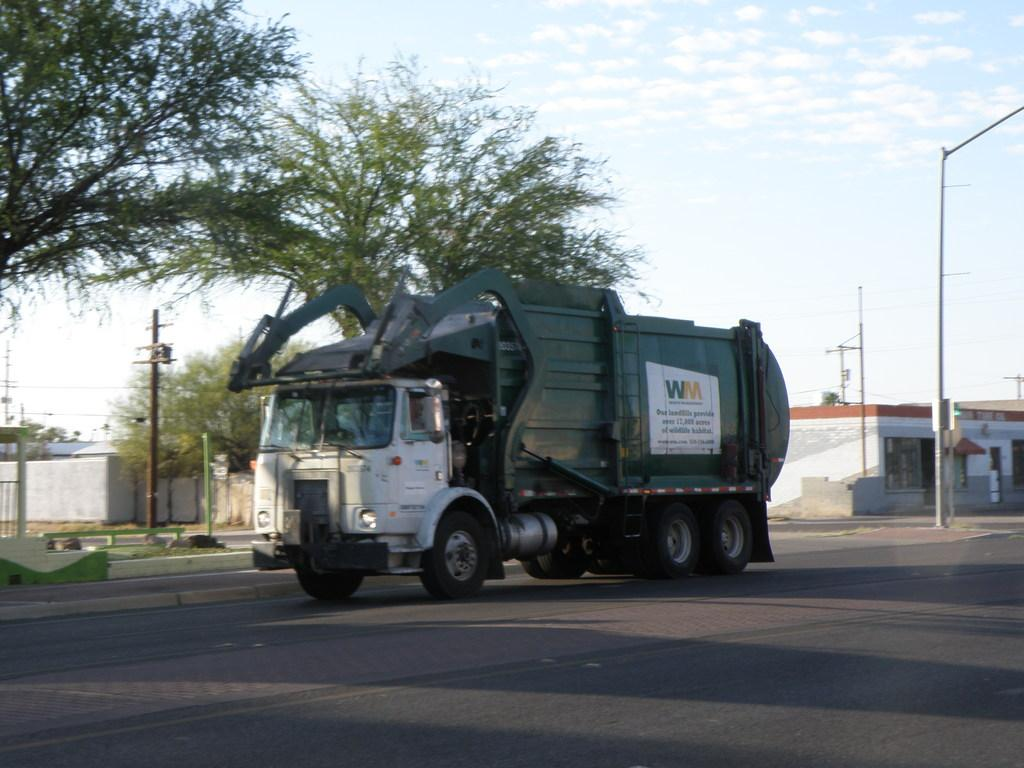What is the main subject of the image? There is a vehicle on the road in the image. What else can be seen in the image besides the vehicle? There are poles, trees, buildings, a wall, and the sky with clouds visible in the background of the image. What type of structures are present in the image? There are buildings and a wall present in the image. What natural elements can be seen in the image? Trees and the sky with clouds can be seen in the image. What type of produce is being harvested in the image? There is no produce or harvesting activity present in the image. What stage of growth can be observed in the plants in the image? There are no plants or growth stages visible in the image. 